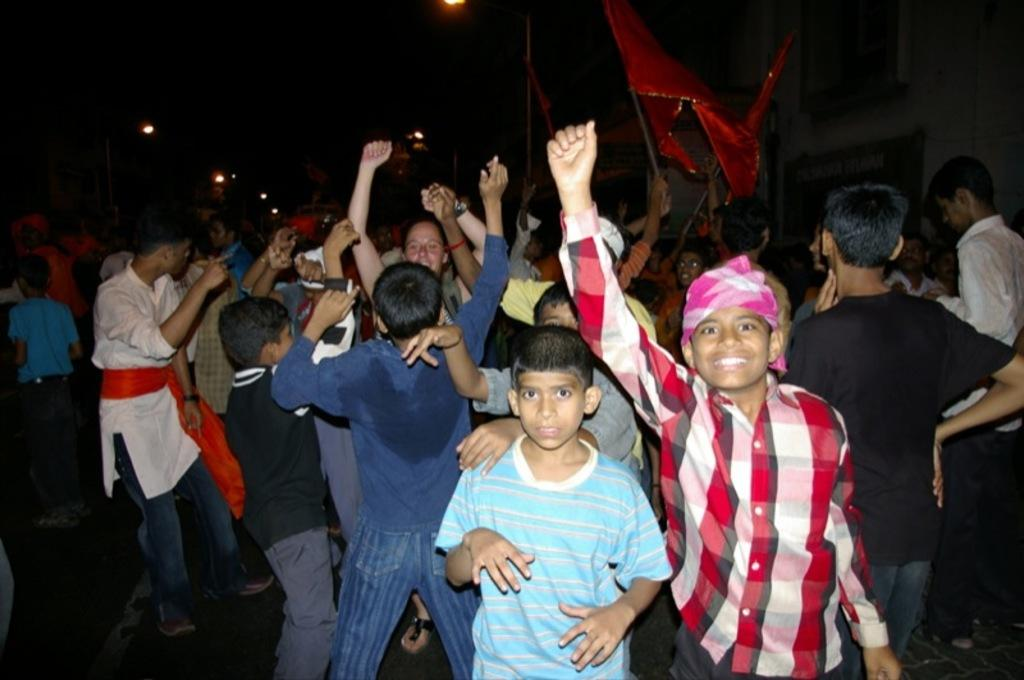What is happening in the image involving the group of people? The people in the image are dancing. How can you describe the attire of the people in the image? The people are wearing different color dresses. Are there any accessories or objects being held by the people in the image? Yes, some people are holding red color flags. What is the color of the background in the image? The background of the image is black. What can be seen in the image that might provide illumination? There are lights visible in the image. What type of quicksand can be seen in the image? There is no quicksand present in the image. What subject is being taught by the people in the image? The image does not depict any teaching or educational activity. 